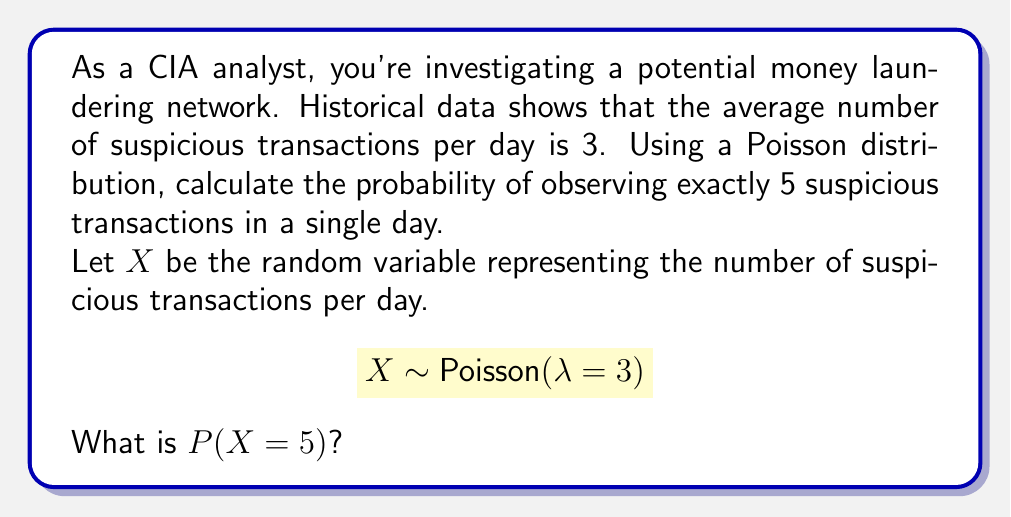Provide a solution to this math problem. To solve this problem, we'll use the Poisson probability mass function:

$$P(X = k) = \frac{e^{-\lambda} \lambda^k}{k!}$$

Where:
- $\lambda$ is the average rate of occurrence (3 in this case)
- $k$ is the number of events we're interested in (5 in this case)
- $e$ is Euler's number (approximately 2.71828)

Step 1: Substitute the values into the formula
$$P(X = 5) = \frac{e^{-3} 3^5}{5!}$$

Step 2: Calculate $3^5$
$$3^5 = 243$$

Step 3: Calculate $5!$
$$5! = 5 \times 4 \times 3 \times 2 \times 1 = 120$$

Step 4: Calculate $e^{-3}$
$$e^{-3} \approx 0.0497871$$

Step 5: Put it all together
$$P(X = 5) = \frac{0.0497871 \times 243}{120}$$

Step 6: Perform the final calculation
$$P(X = 5) \approx 0.1008$$

This result indicates that there is approximately a 10.08% chance of observing exactly 5 suspicious transactions in a single day, given that the average is 3 per day.
Answer: 0.1008 or 10.08% 